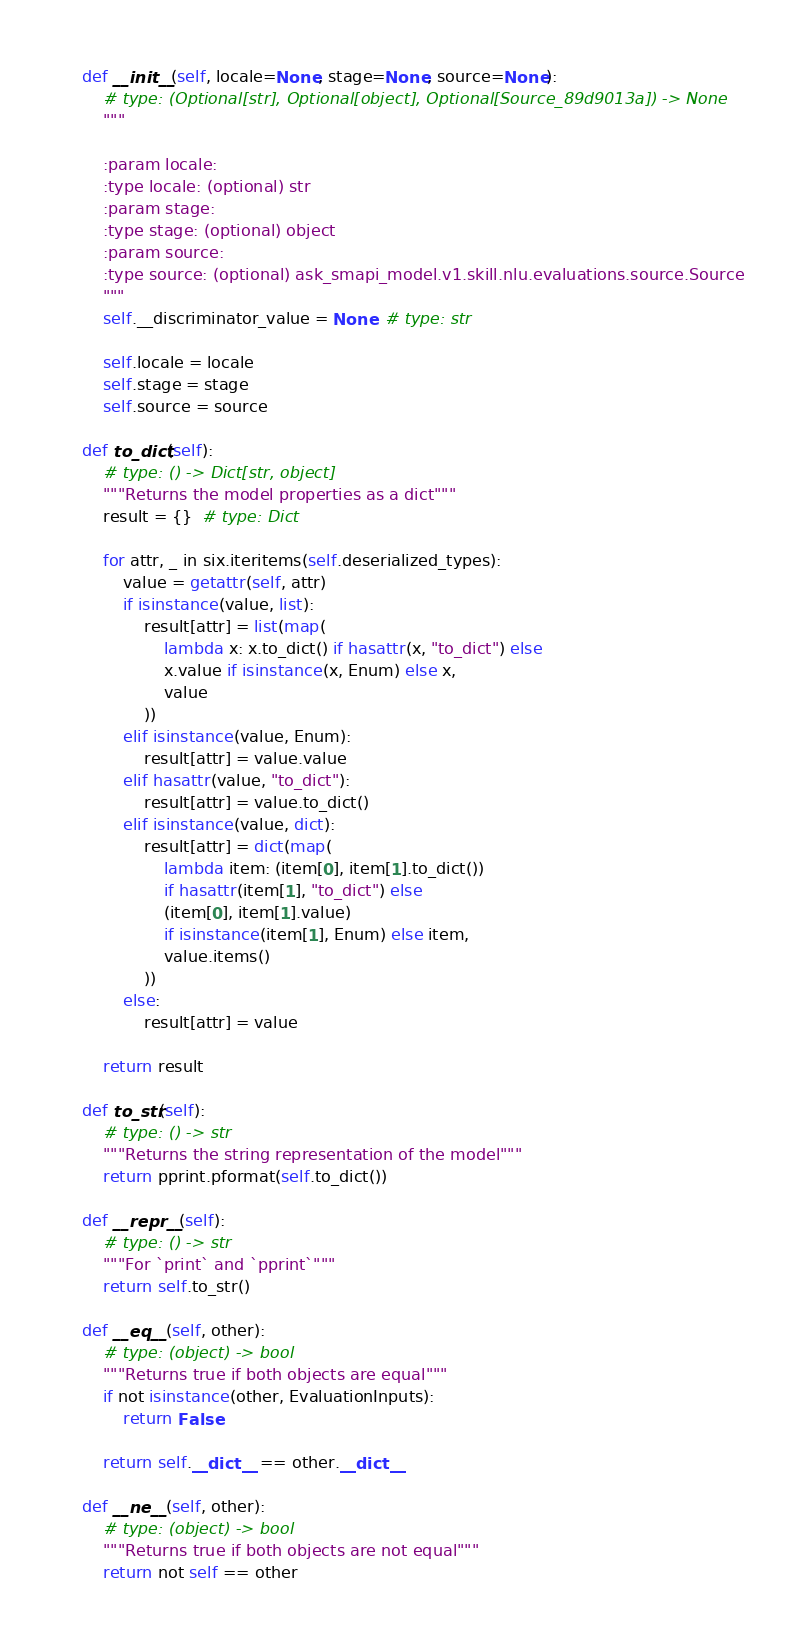<code> <loc_0><loc_0><loc_500><loc_500><_Python_>    def __init__(self, locale=None, stage=None, source=None):
        # type: (Optional[str], Optional[object], Optional[Source_89d9013a]) -> None
        """

        :param locale: 
        :type locale: (optional) str
        :param stage: 
        :type stage: (optional) object
        :param source: 
        :type source: (optional) ask_smapi_model.v1.skill.nlu.evaluations.source.Source
        """
        self.__discriminator_value = None  # type: str

        self.locale = locale
        self.stage = stage
        self.source = source

    def to_dict(self):
        # type: () -> Dict[str, object]
        """Returns the model properties as a dict"""
        result = {}  # type: Dict

        for attr, _ in six.iteritems(self.deserialized_types):
            value = getattr(self, attr)
            if isinstance(value, list):
                result[attr] = list(map(
                    lambda x: x.to_dict() if hasattr(x, "to_dict") else
                    x.value if isinstance(x, Enum) else x,
                    value
                ))
            elif isinstance(value, Enum):
                result[attr] = value.value
            elif hasattr(value, "to_dict"):
                result[attr] = value.to_dict()
            elif isinstance(value, dict):
                result[attr] = dict(map(
                    lambda item: (item[0], item[1].to_dict())
                    if hasattr(item[1], "to_dict") else
                    (item[0], item[1].value)
                    if isinstance(item[1], Enum) else item,
                    value.items()
                ))
            else:
                result[attr] = value

        return result

    def to_str(self):
        # type: () -> str
        """Returns the string representation of the model"""
        return pprint.pformat(self.to_dict())

    def __repr__(self):
        # type: () -> str
        """For `print` and `pprint`"""
        return self.to_str()

    def __eq__(self, other):
        # type: (object) -> bool
        """Returns true if both objects are equal"""
        if not isinstance(other, EvaluationInputs):
            return False

        return self.__dict__ == other.__dict__

    def __ne__(self, other):
        # type: (object) -> bool
        """Returns true if both objects are not equal"""
        return not self == other
</code> 